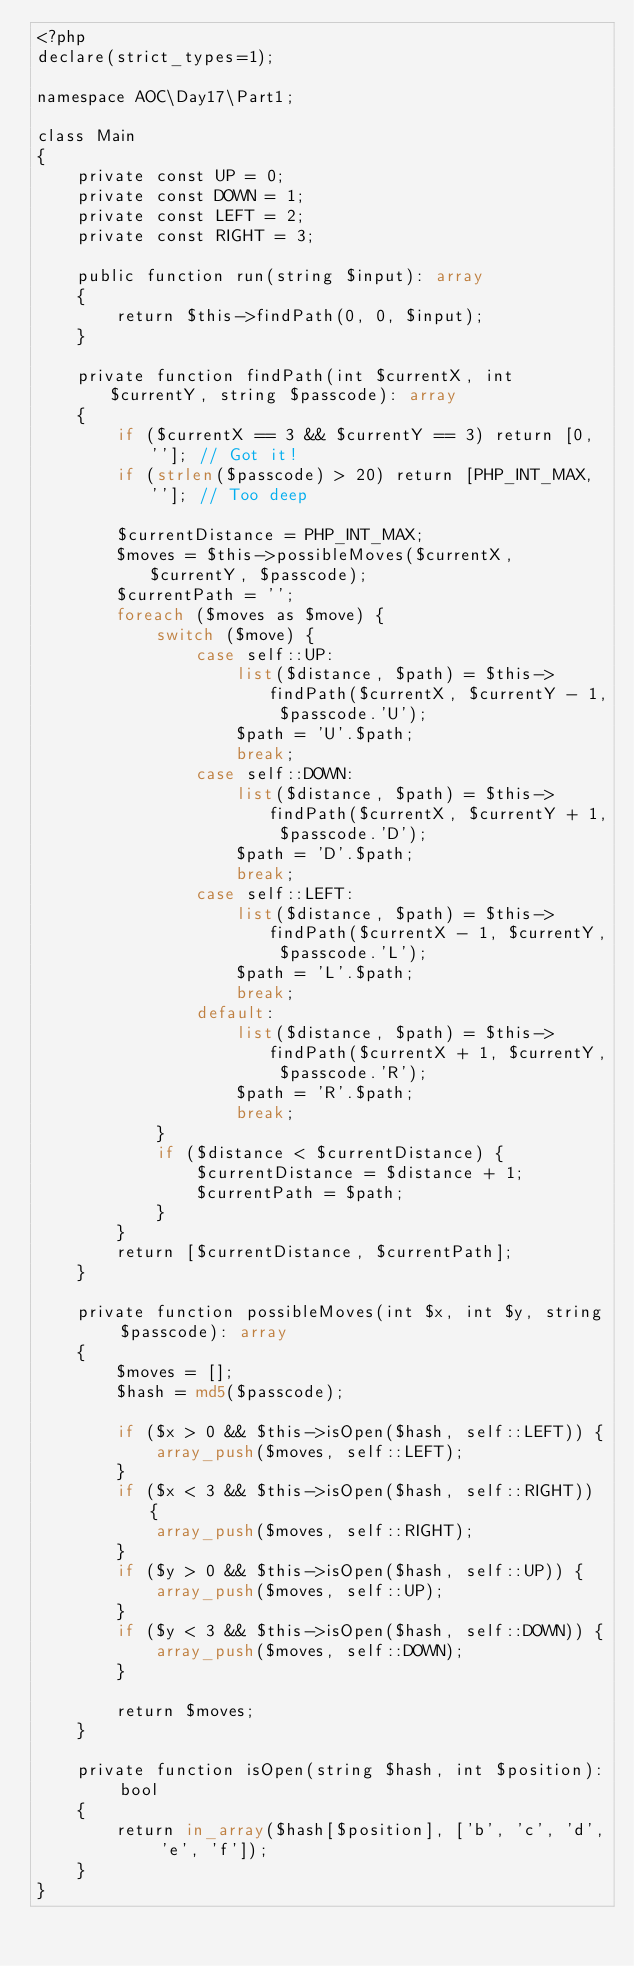<code> <loc_0><loc_0><loc_500><loc_500><_PHP_><?php
declare(strict_types=1);

namespace AOC\Day17\Part1;

class Main
{
    private const UP = 0;
    private const DOWN = 1;
    private const LEFT = 2;
    private const RIGHT = 3;

    public function run(string $input): array
    {
        return $this->findPath(0, 0, $input);
    }

    private function findPath(int $currentX, int $currentY, string $passcode): array
    {
        if ($currentX == 3 && $currentY == 3) return [0, '']; // Got it!
        if (strlen($passcode) > 20) return [PHP_INT_MAX, '']; // Too deep

        $currentDistance = PHP_INT_MAX;
        $moves = $this->possibleMoves($currentX, $currentY, $passcode);
        $currentPath = '';
        foreach ($moves as $move) {
            switch ($move) {
                case self::UP:
                    list($distance, $path) = $this->findPath($currentX, $currentY - 1, $passcode.'U');
                    $path = 'U'.$path;
                    break;
                case self::DOWN:
                    list($distance, $path) = $this->findPath($currentX, $currentY + 1, $passcode.'D');
                    $path = 'D'.$path;
                    break;
                case self::LEFT:
                    list($distance, $path) = $this->findPath($currentX - 1, $currentY, $passcode.'L');
                    $path = 'L'.$path;
                    break;
                default:
                    list($distance, $path) = $this->findPath($currentX + 1, $currentY, $passcode.'R');
                    $path = 'R'.$path;
                    break;
            }
            if ($distance < $currentDistance) {
                $currentDistance = $distance + 1;
                $currentPath = $path;
            }
        }
        return [$currentDistance, $currentPath];
    }

    private function possibleMoves(int $x, int $y, string $passcode): array
    {
        $moves = [];
        $hash = md5($passcode);

        if ($x > 0 && $this->isOpen($hash, self::LEFT)) {
            array_push($moves, self::LEFT);
        }
        if ($x < 3 && $this->isOpen($hash, self::RIGHT)) {
            array_push($moves, self::RIGHT);
        }
        if ($y > 0 && $this->isOpen($hash, self::UP)) {
            array_push($moves, self::UP);
        }
        if ($y < 3 && $this->isOpen($hash, self::DOWN)) {
            array_push($moves, self::DOWN);
        }

        return $moves;
    }

    private function isOpen(string $hash, int $position): bool
    {
        return in_array($hash[$position], ['b', 'c', 'd', 'e', 'f']);
    }
}
</code> 